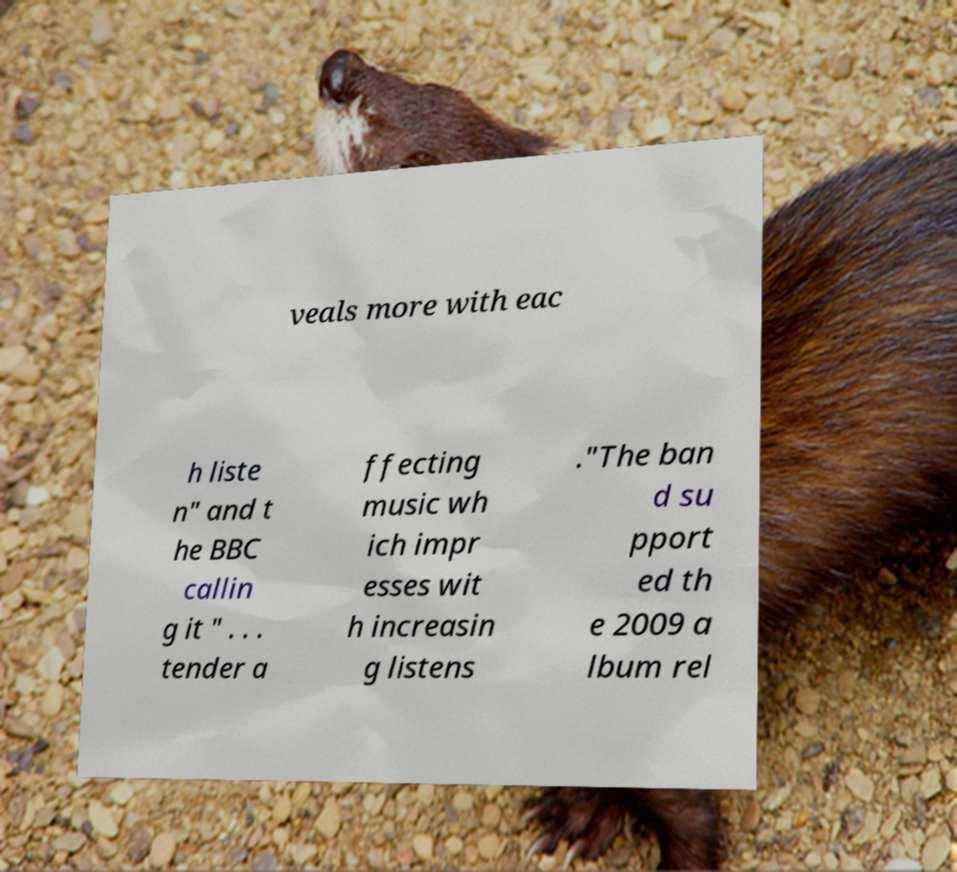Please read and relay the text visible in this image. What does it say? veals more with eac h liste n" and t he BBC callin g it " . . . tender a ffecting music wh ich impr esses wit h increasin g listens ."The ban d su pport ed th e 2009 a lbum rel 